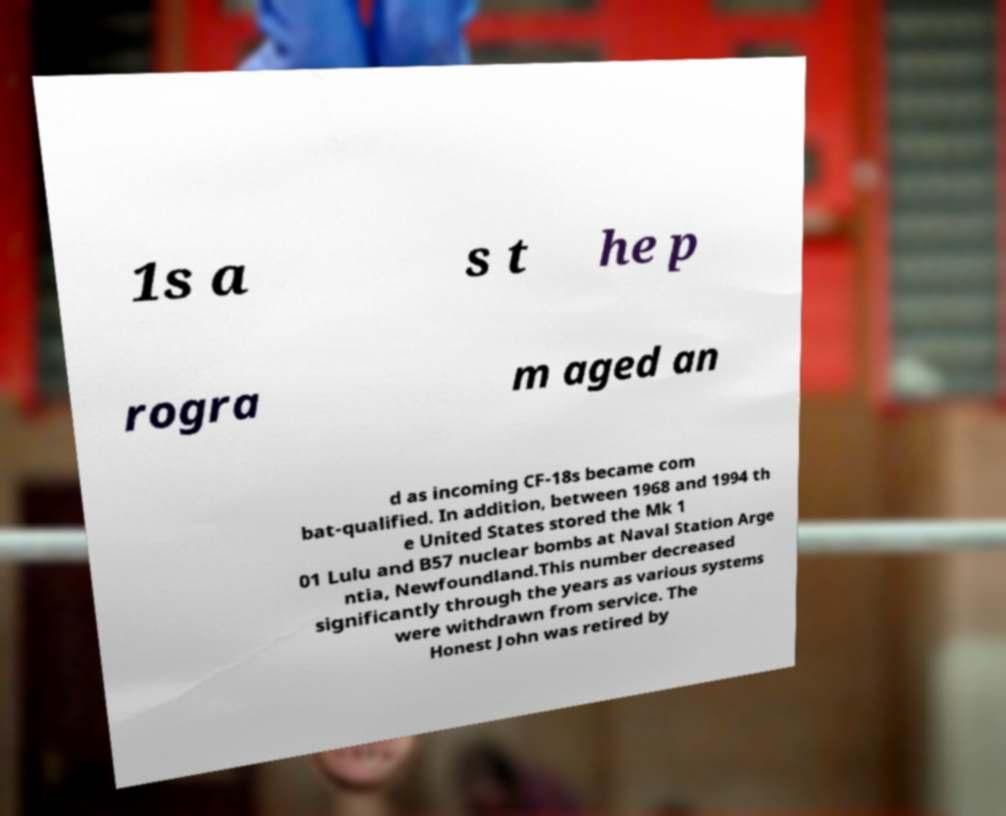Could you assist in decoding the text presented in this image and type it out clearly? 1s a s t he p rogra m aged an d as incoming CF-18s became com bat-qualified. In addition, between 1968 and 1994 th e United States stored the Mk 1 01 Lulu and B57 nuclear bombs at Naval Station Arge ntia, Newfoundland.This number decreased significantly through the years as various systems were withdrawn from service. The Honest John was retired by 